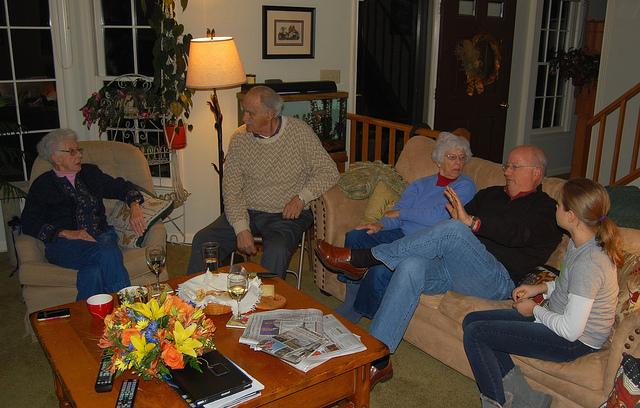What nationality are these people?
Quick response, please. American. Is this a government meeting?
Keep it brief. No. Is this indoors?
Keep it brief. Yes. Name something on the table?
Answer briefly. Remotes. Is there a candle on the coffee table?
Short answer required. No. Is the woman wearing boots?
Answer briefly. Yes. Is there a plant on the table?
Concise answer only. Yes. Do these people appear to be Caucasian?
Short answer required. Yes. How many fingers does grandma on the far left have showing?
Concise answer only. 8. How many women are wearing scarves?
Be succinct. 0. How many people do you see?
Give a very brief answer. 5. How many people are in the picture?
Concise answer only. 5. Is this the living room?
Give a very brief answer. Yes. What age group are most of these people in?
Concise answer only. Elderly. 